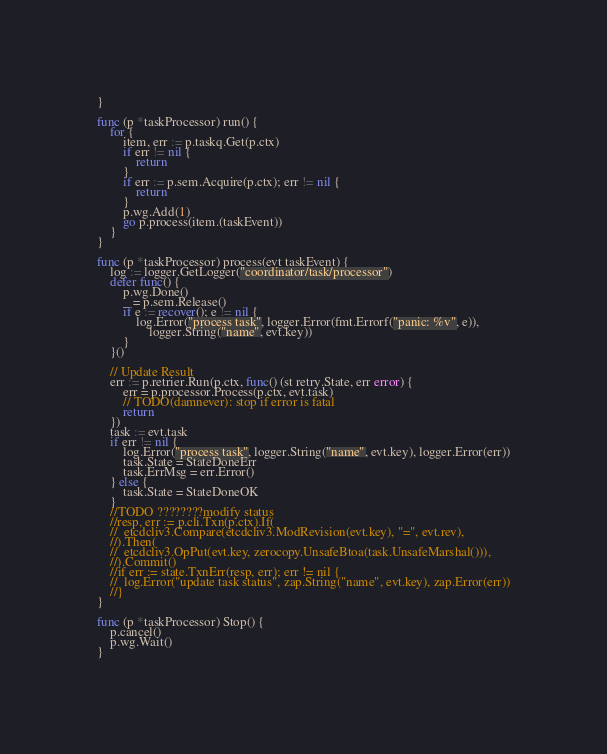<code> <loc_0><loc_0><loc_500><loc_500><_Go_>}

func (p *taskProcessor) run() {
	for {
		item, err := p.taskq.Get(p.ctx)
		if err != nil {
			return
		}
		if err := p.sem.Acquire(p.ctx); err != nil {
			return
		}
		p.wg.Add(1)
		go p.process(item.(taskEvent))
	}
}

func (p *taskProcessor) process(evt taskEvent) {
	log := logger.GetLogger("coordinator/task/processor")
	defer func() {
		p.wg.Done()
		_ = p.sem.Release()
		if e := recover(); e != nil {
			log.Error("process task", logger.Error(fmt.Errorf("panic: %v", e)),
				logger.String("name", evt.key))
		}
	}()

	// Update Result
	err := p.retrier.Run(p.ctx, func() (st retry.State, err error) {
		err = p.processor.Process(p.ctx, evt.task)
		// TODO(damnever): stop if error is fatal
		return
	})
	task := evt.task
	if err != nil {
		log.Error("process task", logger.String("name", evt.key), logger.Error(err))
		task.State = StateDoneErr
		task.ErrMsg = err.Error()
	} else {
		task.State = StateDoneOK
	}
	//TODO ????????modify status
	//resp, err := p.cli.Txn(p.ctx).If(
	//	etcdcliv3.Compare(etcdcliv3.ModRevision(evt.key), "=", evt.rev),
	//).Then(
	//	etcdcliv3.OpPut(evt.key, zerocopy.UnsafeBtoa(task.UnsafeMarshal())),
	//).Commit()
	//if err := state.TxnErr(resp, err); err != nil {
	//	log.Error("update task status", zap.String("name", evt.key), zap.Error(err))
	//}
}

func (p *taskProcessor) Stop() {
	p.cancel()
	p.wg.Wait()
}
</code> 